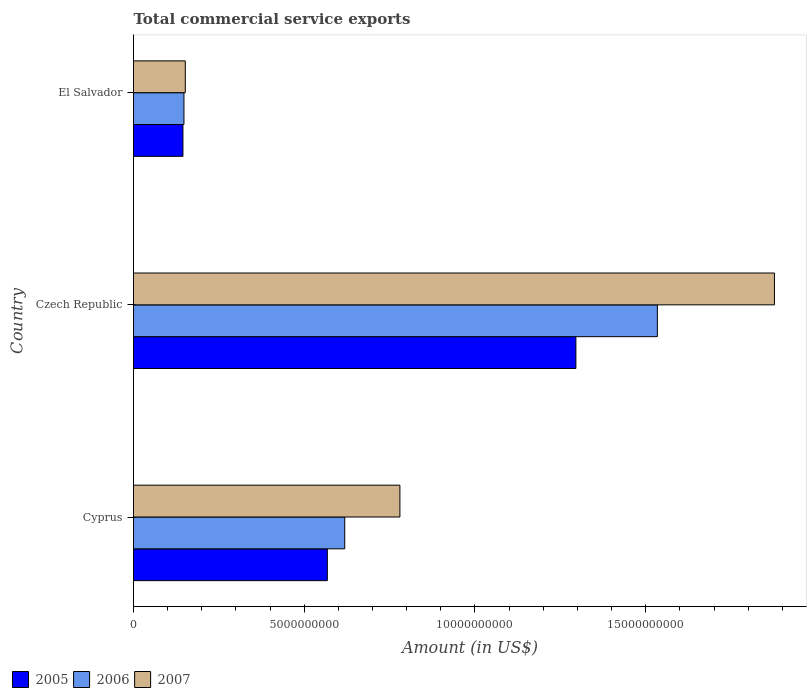Are the number of bars on each tick of the Y-axis equal?
Offer a very short reply. Yes. How many bars are there on the 3rd tick from the top?
Ensure brevity in your answer.  3. How many bars are there on the 3rd tick from the bottom?
Provide a short and direct response. 3. What is the label of the 1st group of bars from the top?
Provide a succinct answer. El Salvador. What is the total commercial service exports in 2005 in Cyprus?
Offer a very short reply. 5.68e+09. Across all countries, what is the maximum total commercial service exports in 2007?
Offer a terse response. 1.88e+1. Across all countries, what is the minimum total commercial service exports in 2006?
Give a very brief answer. 1.48e+09. In which country was the total commercial service exports in 2007 maximum?
Provide a short and direct response. Czech Republic. In which country was the total commercial service exports in 2005 minimum?
Your response must be concise. El Salvador. What is the total total commercial service exports in 2005 in the graph?
Provide a succinct answer. 2.01e+1. What is the difference between the total commercial service exports in 2005 in Czech Republic and that in El Salvador?
Offer a terse response. 1.15e+1. What is the difference between the total commercial service exports in 2007 in El Salvador and the total commercial service exports in 2006 in Czech Republic?
Keep it short and to the point. -1.38e+1. What is the average total commercial service exports in 2006 per country?
Give a very brief answer. 7.67e+09. What is the difference between the total commercial service exports in 2006 and total commercial service exports in 2005 in El Salvador?
Provide a short and direct response. 2.94e+07. In how many countries, is the total commercial service exports in 2006 greater than 17000000000 US$?
Keep it short and to the point. 0. What is the ratio of the total commercial service exports in 2006 in Cyprus to that in Czech Republic?
Offer a very short reply. 0.4. Is the total commercial service exports in 2007 in Czech Republic less than that in El Salvador?
Ensure brevity in your answer.  No. Is the difference between the total commercial service exports in 2006 in Cyprus and El Salvador greater than the difference between the total commercial service exports in 2005 in Cyprus and El Salvador?
Ensure brevity in your answer.  Yes. What is the difference between the highest and the second highest total commercial service exports in 2005?
Your answer should be compact. 7.28e+09. What is the difference between the highest and the lowest total commercial service exports in 2005?
Ensure brevity in your answer.  1.15e+1. In how many countries, is the total commercial service exports in 2005 greater than the average total commercial service exports in 2005 taken over all countries?
Your response must be concise. 1. How many bars are there?
Provide a short and direct response. 9. What is the difference between two consecutive major ticks on the X-axis?
Provide a succinct answer. 5.00e+09. Are the values on the major ticks of X-axis written in scientific E-notation?
Offer a terse response. No. Does the graph contain grids?
Give a very brief answer. No. What is the title of the graph?
Offer a terse response. Total commercial service exports. Does "1960" appear as one of the legend labels in the graph?
Keep it short and to the point. No. What is the label or title of the Y-axis?
Your response must be concise. Country. What is the Amount (in US$) of 2005 in Cyprus?
Offer a very short reply. 5.68e+09. What is the Amount (in US$) of 2006 in Cyprus?
Ensure brevity in your answer.  6.19e+09. What is the Amount (in US$) in 2007 in Cyprus?
Keep it short and to the point. 7.80e+09. What is the Amount (in US$) in 2005 in Czech Republic?
Give a very brief answer. 1.30e+1. What is the Amount (in US$) in 2006 in Czech Republic?
Make the answer very short. 1.53e+1. What is the Amount (in US$) in 2007 in Czech Republic?
Keep it short and to the point. 1.88e+1. What is the Amount (in US$) of 2005 in El Salvador?
Keep it short and to the point. 1.45e+09. What is the Amount (in US$) of 2006 in El Salvador?
Offer a terse response. 1.48e+09. What is the Amount (in US$) in 2007 in El Salvador?
Give a very brief answer. 1.52e+09. Across all countries, what is the maximum Amount (in US$) in 2005?
Your answer should be very brief. 1.30e+1. Across all countries, what is the maximum Amount (in US$) of 2006?
Your answer should be compact. 1.53e+1. Across all countries, what is the maximum Amount (in US$) of 2007?
Your answer should be compact. 1.88e+1. Across all countries, what is the minimum Amount (in US$) of 2005?
Ensure brevity in your answer.  1.45e+09. Across all countries, what is the minimum Amount (in US$) in 2006?
Provide a succinct answer. 1.48e+09. Across all countries, what is the minimum Amount (in US$) in 2007?
Offer a terse response. 1.52e+09. What is the total Amount (in US$) of 2005 in the graph?
Your answer should be very brief. 2.01e+1. What is the total Amount (in US$) in 2006 in the graph?
Offer a very short reply. 2.30e+1. What is the total Amount (in US$) of 2007 in the graph?
Your answer should be very brief. 2.81e+1. What is the difference between the Amount (in US$) in 2005 in Cyprus and that in Czech Republic?
Make the answer very short. -7.28e+09. What is the difference between the Amount (in US$) in 2006 in Cyprus and that in Czech Republic?
Provide a short and direct response. -9.16e+09. What is the difference between the Amount (in US$) in 2007 in Cyprus and that in Czech Republic?
Your answer should be compact. -1.10e+1. What is the difference between the Amount (in US$) of 2005 in Cyprus and that in El Salvador?
Offer a terse response. 4.23e+09. What is the difference between the Amount (in US$) of 2006 in Cyprus and that in El Salvador?
Offer a terse response. 4.71e+09. What is the difference between the Amount (in US$) of 2007 in Cyprus and that in El Salvador?
Give a very brief answer. 6.29e+09. What is the difference between the Amount (in US$) in 2005 in Czech Republic and that in El Salvador?
Offer a terse response. 1.15e+1. What is the difference between the Amount (in US$) of 2006 in Czech Republic and that in El Salvador?
Your answer should be compact. 1.39e+1. What is the difference between the Amount (in US$) of 2007 in Czech Republic and that in El Salvador?
Your answer should be compact. 1.73e+1. What is the difference between the Amount (in US$) of 2005 in Cyprus and the Amount (in US$) of 2006 in Czech Republic?
Ensure brevity in your answer.  -9.66e+09. What is the difference between the Amount (in US$) of 2005 in Cyprus and the Amount (in US$) of 2007 in Czech Republic?
Provide a short and direct response. -1.31e+1. What is the difference between the Amount (in US$) in 2006 in Cyprus and the Amount (in US$) in 2007 in Czech Republic?
Your response must be concise. -1.26e+1. What is the difference between the Amount (in US$) of 2005 in Cyprus and the Amount (in US$) of 2006 in El Salvador?
Keep it short and to the point. 4.20e+09. What is the difference between the Amount (in US$) of 2005 in Cyprus and the Amount (in US$) of 2007 in El Salvador?
Your answer should be compact. 4.16e+09. What is the difference between the Amount (in US$) of 2006 in Cyprus and the Amount (in US$) of 2007 in El Salvador?
Provide a short and direct response. 4.67e+09. What is the difference between the Amount (in US$) of 2005 in Czech Republic and the Amount (in US$) of 2006 in El Salvador?
Provide a succinct answer. 1.15e+1. What is the difference between the Amount (in US$) of 2005 in Czech Republic and the Amount (in US$) of 2007 in El Salvador?
Offer a terse response. 1.14e+1. What is the difference between the Amount (in US$) of 2006 in Czech Republic and the Amount (in US$) of 2007 in El Salvador?
Your answer should be very brief. 1.38e+1. What is the average Amount (in US$) of 2005 per country?
Give a very brief answer. 6.69e+09. What is the average Amount (in US$) in 2006 per country?
Your answer should be very brief. 7.67e+09. What is the average Amount (in US$) in 2007 per country?
Offer a very short reply. 9.36e+09. What is the difference between the Amount (in US$) of 2005 and Amount (in US$) of 2006 in Cyprus?
Offer a terse response. -5.09e+08. What is the difference between the Amount (in US$) of 2005 and Amount (in US$) of 2007 in Cyprus?
Offer a terse response. -2.12e+09. What is the difference between the Amount (in US$) in 2006 and Amount (in US$) in 2007 in Cyprus?
Make the answer very short. -1.62e+09. What is the difference between the Amount (in US$) in 2005 and Amount (in US$) in 2006 in Czech Republic?
Your response must be concise. -2.39e+09. What is the difference between the Amount (in US$) in 2005 and Amount (in US$) in 2007 in Czech Republic?
Provide a short and direct response. -5.81e+09. What is the difference between the Amount (in US$) in 2006 and Amount (in US$) in 2007 in Czech Republic?
Your answer should be very brief. -3.43e+09. What is the difference between the Amount (in US$) of 2005 and Amount (in US$) of 2006 in El Salvador?
Give a very brief answer. -2.94e+07. What is the difference between the Amount (in US$) in 2005 and Amount (in US$) in 2007 in El Salvador?
Your response must be concise. -6.83e+07. What is the difference between the Amount (in US$) in 2006 and Amount (in US$) in 2007 in El Salvador?
Provide a succinct answer. -3.89e+07. What is the ratio of the Amount (in US$) of 2005 in Cyprus to that in Czech Republic?
Ensure brevity in your answer.  0.44. What is the ratio of the Amount (in US$) of 2006 in Cyprus to that in Czech Republic?
Your response must be concise. 0.4. What is the ratio of the Amount (in US$) in 2007 in Cyprus to that in Czech Republic?
Your answer should be compact. 0.42. What is the ratio of the Amount (in US$) in 2005 in Cyprus to that in El Salvador?
Keep it short and to the point. 3.92. What is the ratio of the Amount (in US$) of 2006 in Cyprus to that in El Salvador?
Keep it short and to the point. 4.19. What is the ratio of the Amount (in US$) in 2007 in Cyprus to that in El Salvador?
Make the answer very short. 5.15. What is the ratio of the Amount (in US$) in 2005 in Czech Republic to that in El Salvador?
Ensure brevity in your answer.  8.95. What is the ratio of the Amount (in US$) of 2006 in Czech Republic to that in El Salvador?
Your response must be concise. 10.39. What is the ratio of the Amount (in US$) in 2007 in Czech Republic to that in El Salvador?
Your response must be concise. 12.38. What is the difference between the highest and the second highest Amount (in US$) in 2005?
Ensure brevity in your answer.  7.28e+09. What is the difference between the highest and the second highest Amount (in US$) of 2006?
Offer a very short reply. 9.16e+09. What is the difference between the highest and the second highest Amount (in US$) of 2007?
Offer a terse response. 1.10e+1. What is the difference between the highest and the lowest Amount (in US$) in 2005?
Your answer should be very brief. 1.15e+1. What is the difference between the highest and the lowest Amount (in US$) in 2006?
Your answer should be compact. 1.39e+1. What is the difference between the highest and the lowest Amount (in US$) in 2007?
Ensure brevity in your answer.  1.73e+1. 